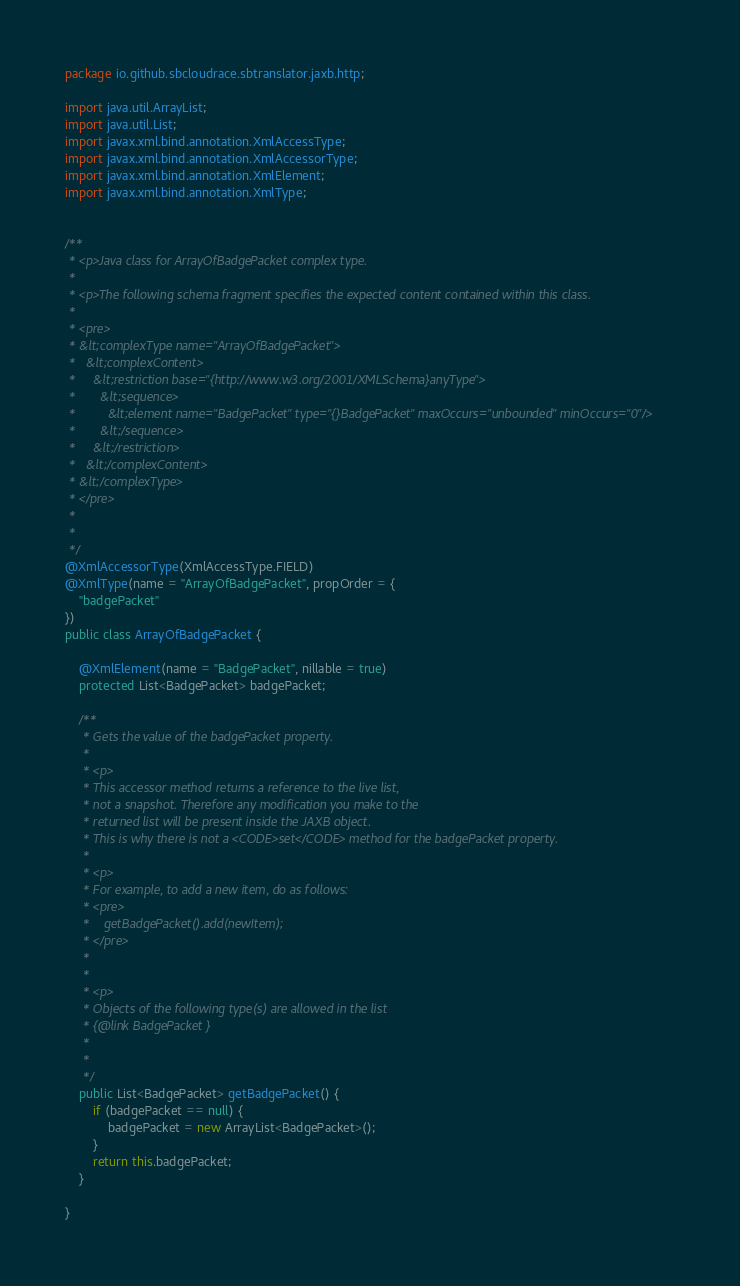Convert code to text. <code><loc_0><loc_0><loc_500><loc_500><_Java_>
package io.github.sbcloudrace.sbtranslator.jaxb.http;

import java.util.ArrayList;
import java.util.List;
import javax.xml.bind.annotation.XmlAccessType;
import javax.xml.bind.annotation.XmlAccessorType;
import javax.xml.bind.annotation.XmlElement;
import javax.xml.bind.annotation.XmlType;


/**
 * <p>Java class for ArrayOfBadgePacket complex type.
 * 
 * <p>The following schema fragment specifies the expected content contained within this class.
 * 
 * <pre>
 * &lt;complexType name="ArrayOfBadgePacket">
 *   &lt;complexContent>
 *     &lt;restriction base="{http://www.w3.org/2001/XMLSchema}anyType">
 *       &lt;sequence>
 *         &lt;element name="BadgePacket" type="{}BadgePacket" maxOccurs="unbounded" minOccurs="0"/>
 *       &lt;/sequence>
 *     &lt;/restriction>
 *   &lt;/complexContent>
 * &lt;/complexType>
 * </pre>
 * 
 * 
 */
@XmlAccessorType(XmlAccessType.FIELD)
@XmlType(name = "ArrayOfBadgePacket", propOrder = {
    "badgePacket"
})
public class ArrayOfBadgePacket {

    @XmlElement(name = "BadgePacket", nillable = true)
    protected List<BadgePacket> badgePacket;

    /**
     * Gets the value of the badgePacket property.
     * 
     * <p>
     * This accessor method returns a reference to the live list,
     * not a snapshot. Therefore any modification you make to the
     * returned list will be present inside the JAXB object.
     * This is why there is not a <CODE>set</CODE> method for the badgePacket property.
     * 
     * <p>
     * For example, to add a new item, do as follows:
     * <pre>
     *    getBadgePacket().add(newItem);
     * </pre>
     * 
     * 
     * <p>
     * Objects of the following type(s) are allowed in the list
     * {@link BadgePacket }
     * 
     * 
     */
    public List<BadgePacket> getBadgePacket() {
        if (badgePacket == null) {
            badgePacket = new ArrayList<BadgePacket>();
        }
        return this.badgePacket;
    }

}
</code> 